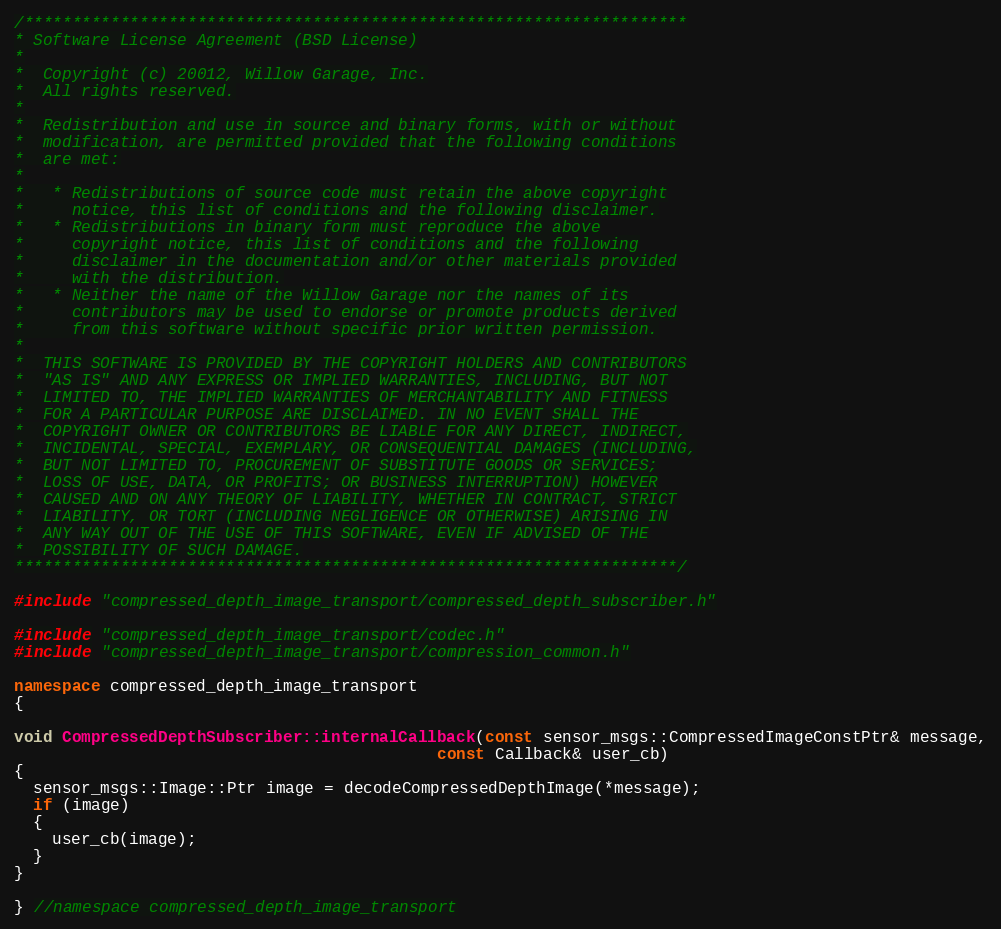<code> <loc_0><loc_0><loc_500><loc_500><_C++_>/*********************************************************************
* Software License Agreement (BSD License)
*
*  Copyright (c) 20012, Willow Garage, Inc.
*  All rights reserved.
*
*  Redistribution and use in source and binary forms, with or without
*  modification, are permitted provided that the following conditions
*  are met:
*
*   * Redistributions of source code must retain the above copyright
*     notice, this list of conditions and the following disclaimer.
*   * Redistributions in binary form must reproduce the above
*     copyright notice, this list of conditions and the following
*     disclaimer in the documentation and/or other materials provided
*     with the distribution.
*   * Neither the name of the Willow Garage nor the names of its
*     contributors may be used to endorse or promote products derived
*     from this software without specific prior written permission.
*
*  THIS SOFTWARE IS PROVIDED BY THE COPYRIGHT HOLDERS AND CONTRIBUTORS
*  "AS IS" AND ANY EXPRESS OR IMPLIED WARRANTIES, INCLUDING, BUT NOT
*  LIMITED TO, THE IMPLIED WARRANTIES OF MERCHANTABILITY AND FITNESS
*  FOR A PARTICULAR PURPOSE ARE DISCLAIMED. IN NO EVENT SHALL THE
*  COPYRIGHT OWNER OR CONTRIBUTORS BE LIABLE FOR ANY DIRECT, INDIRECT,
*  INCIDENTAL, SPECIAL, EXEMPLARY, OR CONSEQUENTIAL DAMAGES (INCLUDING,
*  BUT NOT LIMITED TO, PROCUREMENT OF SUBSTITUTE GOODS OR SERVICES;
*  LOSS OF USE, DATA, OR PROFITS; OR BUSINESS INTERRUPTION) HOWEVER
*  CAUSED AND ON ANY THEORY OF LIABILITY, WHETHER IN CONTRACT, STRICT
*  LIABILITY, OR TORT (INCLUDING NEGLIGENCE OR OTHERWISE) ARISING IN
*  ANY WAY OUT OF THE USE OF THIS SOFTWARE, EVEN IF ADVISED OF THE
*  POSSIBILITY OF SUCH DAMAGE.
*********************************************************************/

#include "compressed_depth_image_transport/compressed_depth_subscriber.h"

#include "compressed_depth_image_transport/codec.h"
#include "compressed_depth_image_transport/compression_common.h"

namespace compressed_depth_image_transport
{

void CompressedDepthSubscriber::internalCallback(const sensor_msgs::CompressedImageConstPtr& message,
                                            const Callback& user_cb)
{
  sensor_msgs::Image::Ptr image = decodeCompressedDepthImage(*message);
  if (image)
  {
    user_cb(image);
  }
}

} //namespace compressed_depth_image_transport
</code> 